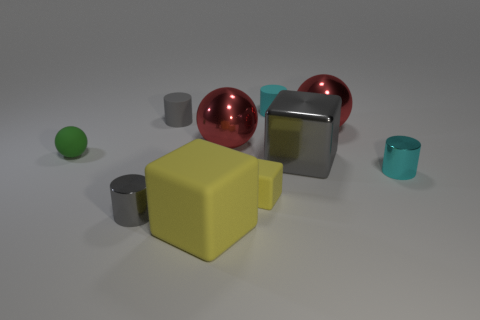Does the large gray block have the same material as the green object?
Give a very brief answer. No. Are there fewer big matte blocks behind the big yellow block than big yellow cubes on the right side of the green ball?
Your response must be concise. Yes. Are there fewer large things that are on the right side of the cyan rubber cylinder than large red metallic objects?
Give a very brief answer. No. There is a cyan cylinder left of the cyan cylinder that is in front of the tiny ball on the left side of the big gray thing; what is it made of?
Your response must be concise. Rubber. How many things are tiny metal things on the right side of the tiny yellow rubber block or large metallic spheres that are to the left of the gray block?
Your answer should be very brief. 2. There is a big gray thing that is the same shape as the tiny yellow object; what material is it?
Your answer should be compact. Metal. What number of metal objects are either balls or tiny green balls?
Give a very brief answer. 2. The small yellow thing that is made of the same material as the small green thing is what shape?
Offer a very short reply. Cube. How many gray matte objects have the same shape as the green matte thing?
Give a very brief answer. 0. Do the gray object that is behind the green thing and the big gray thing in front of the tiny green object have the same shape?
Provide a short and direct response. No. 